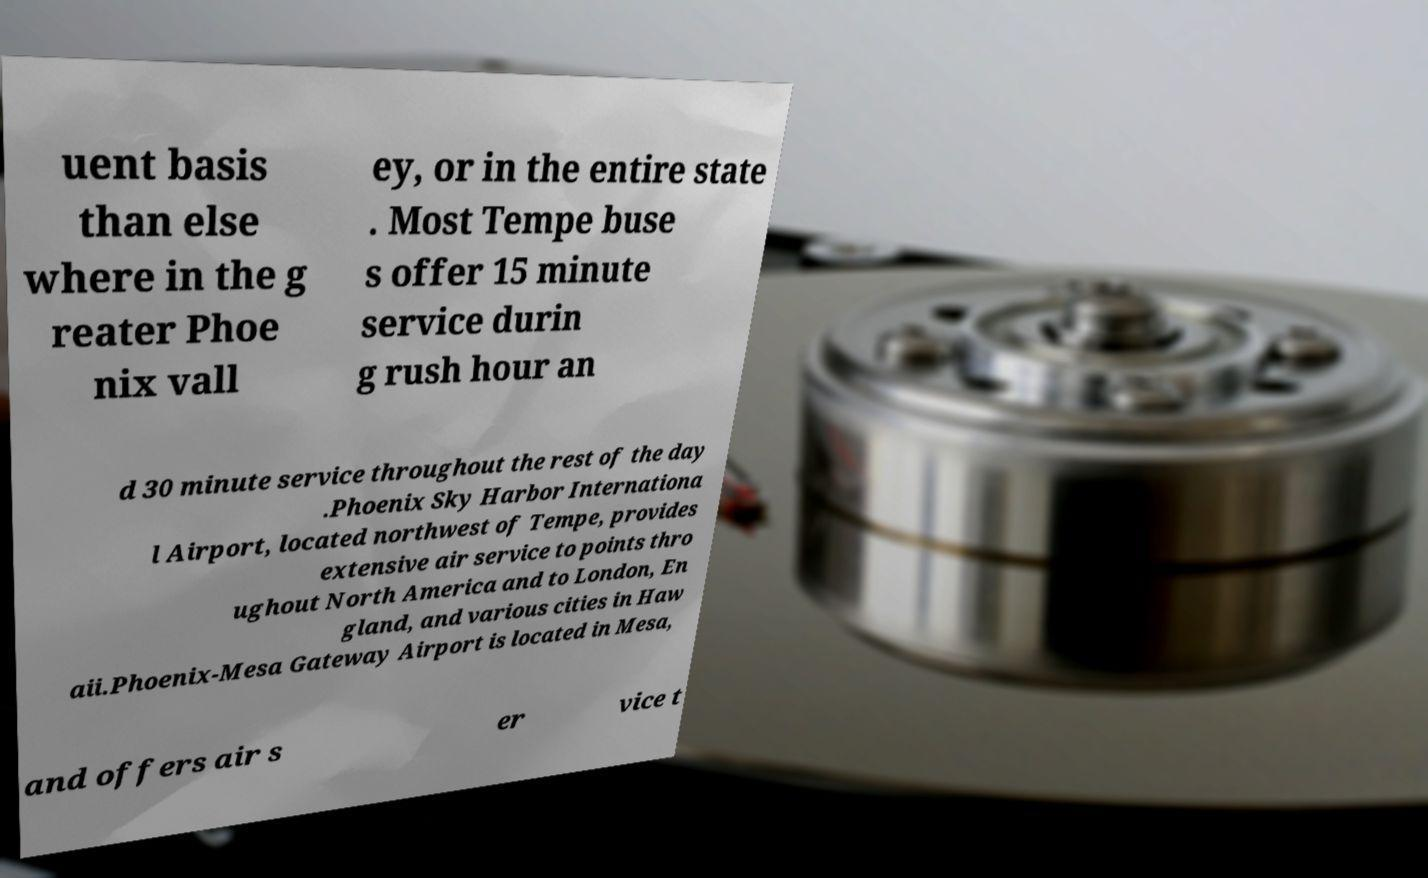Please identify and transcribe the text found in this image. uent basis than else where in the g reater Phoe nix vall ey, or in the entire state . Most Tempe buse s offer 15 minute service durin g rush hour an d 30 minute service throughout the rest of the day .Phoenix Sky Harbor Internationa l Airport, located northwest of Tempe, provides extensive air service to points thro ughout North America and to London, En gland, and various cities in Haw aii.Phoenix-Mesa Gateway Airport is located in Mesa, and offers air s er vice t 